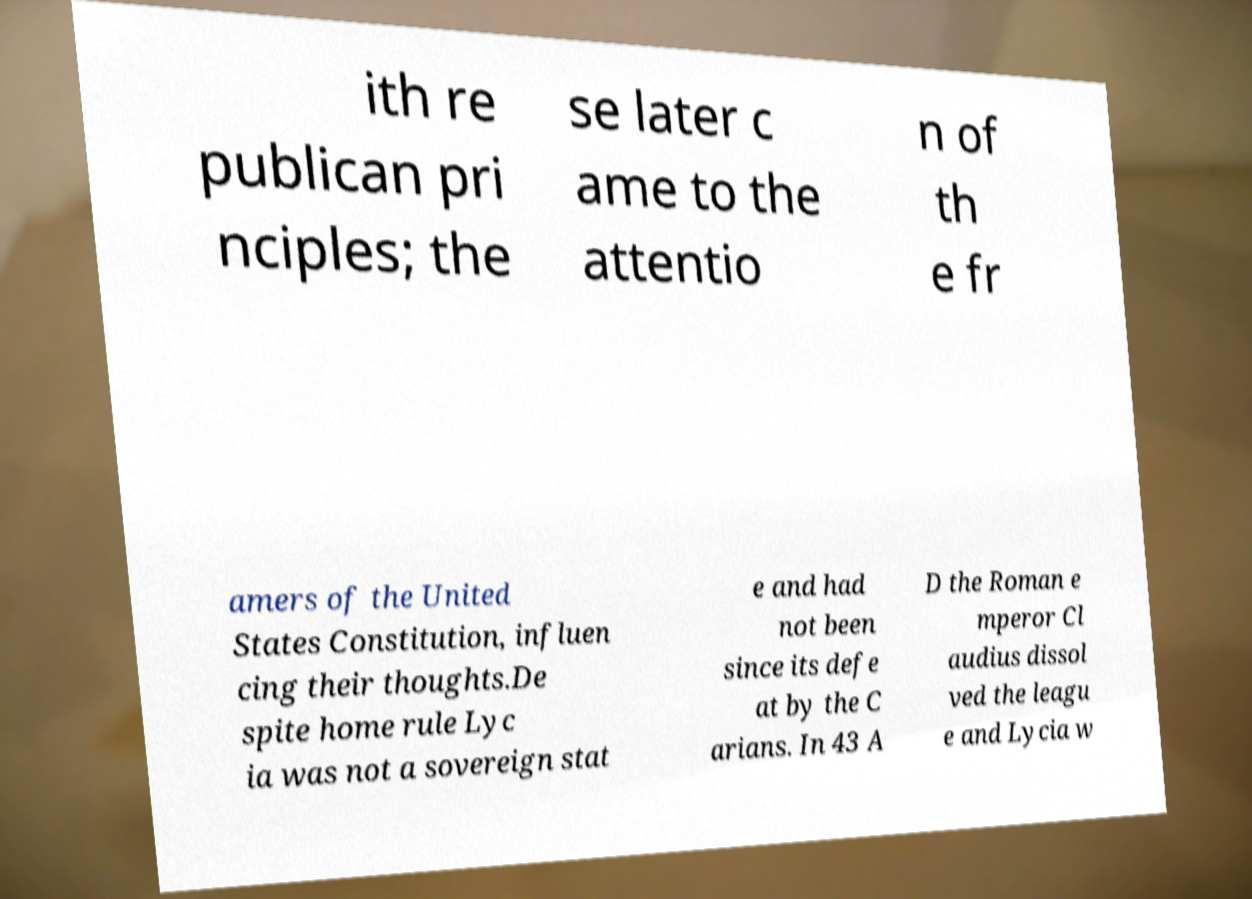There's text embedded in this image that I need extracted. Can you transcribe it verbatim? ith re publican pri nciples; the se later c ame to the attentio n of th e fr amers of the United States Constitution, influen cing their thoughts.De spite home rule Lyc ia was not a sovereign stat e and had not been since its defe at by the C arians. In 43 A D the Roman e mperor Cl audius dissol ved the leagu e and Lycia w 